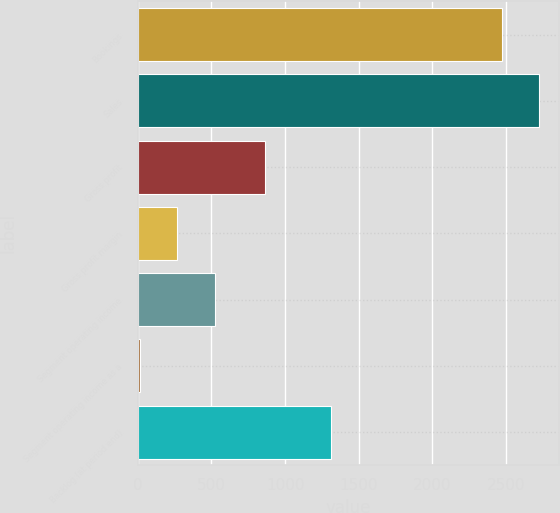Convert chart. <chart><loc_0><loc_0><loc_500><loc_500><bar_chart><fcel>Bookings<fcel>Sales<fcel>Gross profit<fcel>Gross profit margin<fcel>Segment operating income<fcel>Segment operating income as a<fcel>Backlog (at period end)<nl><fcel>2474.1<fcel>2726.14<fcel>861.3<fcel>268.74<fcel>520.78<fcel>16.7<fcel>1311.4<nl></chart> 